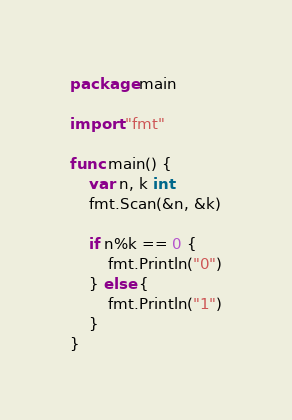Convert code to text. <code><loc_0><loc_0><loc_500><loc_500><_Go_>package main

import "fmt"

func main() {
	var n, k int
	fmt.Scan(&n, &k)

	if n%k == 0 {
		fmt.Println("0")
	} else {
		fmt.Println("1")
	}
}
</code> 